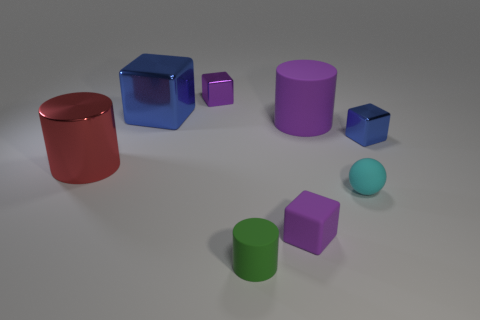What is the shape of the blue metal thing that is the same size as the green rubber cylinder?
Your response must be concise. Cube. There is a object that is the same color as the large cube; what material is it?
Your response must be concise. Metal. There is a large purple rubber cylinder; are there any blocks behind it?
Your answer should be very brief. Yes. Are there any red objects of the same shape as the small blue metallic thing?
Your answer should be compact. No. There is a small metallic thing that is to the left of the big purple thing; is it the same shape as the blue thing that is on the right side of the big rubber cylinder?
Offer a terse response. Yes. Are there any other green rubber cylinders of the same size as the green cylinder?
Your answer should be compact. No. Are there the same number of objects to the right of the matte cube and small shiny objects that are left of the small green matte cylinder?
Offer a terse response. No. Is the material of the object right of the small cyan matte sphere the same as the cylinder on the left side of the small purple metallic block?
Ensure brevity in your answer.  Yes. What is the tiny blue thing made of?
Make the answer very short. Metal. How many other things are the same color as the big matte object?
Offer a very short reply. 2. 